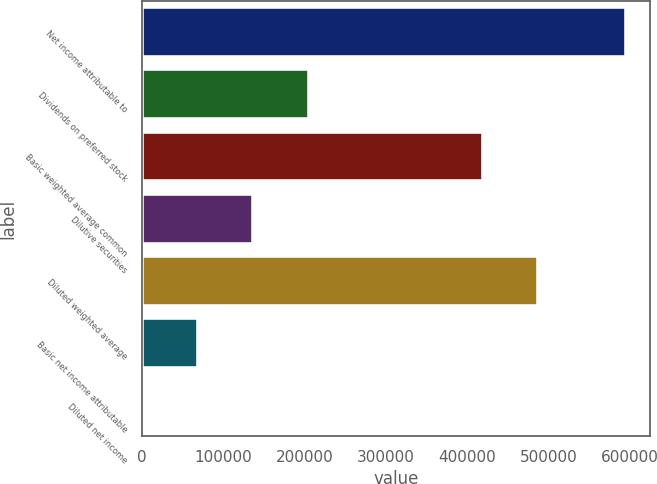Convert chart to OTSL. <chart><loc_0><loc_0><loc_500><loc_500><bar_chart><fcel>Net income attributable to<fcel>Dividends on preferred stock<fcel>Basic weighted average common<fcel>Dilutive securities<fcel>Diluted weighted average<fcel>Basic net income attributable<fcel>Diluted net income<nl><fcel>594911<fcel>205523<fcel>418907<fcel>137016<fcel>487414<fcel>68508.7<fcel>1.41<nl></chart> 